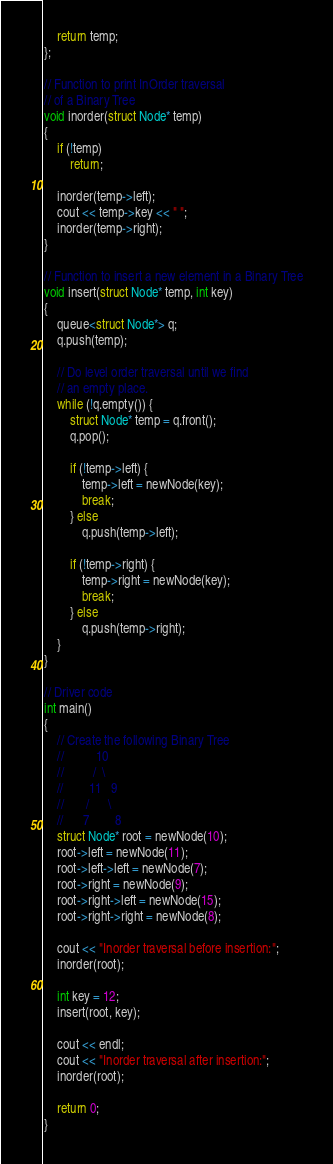<code> <loc_0><loc_0><loc_500><loc_500><_C++_>    return temp; 
}; 

// Function to print InOrder traversal 
// of a Binary Tree
void inorder(struct Node* temp) 
{ 
    if (!temp) 
        return; 

    inorder(temp->left); 
    cout << temp->key << " "; 
    inorder(temp->right); 
} 

// Function to insert a new element in a Binary Tree
void insert(struct Node* temp, int key) 
{ 
    queue<struct Node*> q; 
    q.push(temp); 

    // Do level order traversal until we find 
    // an empty place. 
    while (!q.empty()) { 
        struct Node* temp = q.front(); 
        q.pop(); 

        if (!temp->left) { 
            temp->left = newNode(key); 
            break; 
        } else
            q.push(temp->left); 

        if (!temp->right) { 
            temp->right = newNode(key); 
            break; 
        } else
            q.push(temp->right); 
    } 
} 

// Driver code 
int main() 
{   
    // Create the following Binary Tree
    //          10
    //         /  \
    //        11   9
    //       /      \
    //      7        8
    struct Node* root = newNode(10); 
    root->left = newNode(11); 
    root->left->left = newNode(7); 
    root->right = newNode(9); 
    root->right->left = newNode(15); 
    root->right->right = newNode(8); 

    cout << "Inorder traversal before insertion:"; 
    inorder(root); 

    int key = 12; 
    insert(root, key); 

    cout << endl; 
    cout << "Inorder traversal after insertion:"; 
    inorder(root); 

    return 0; 
} 
</code> 